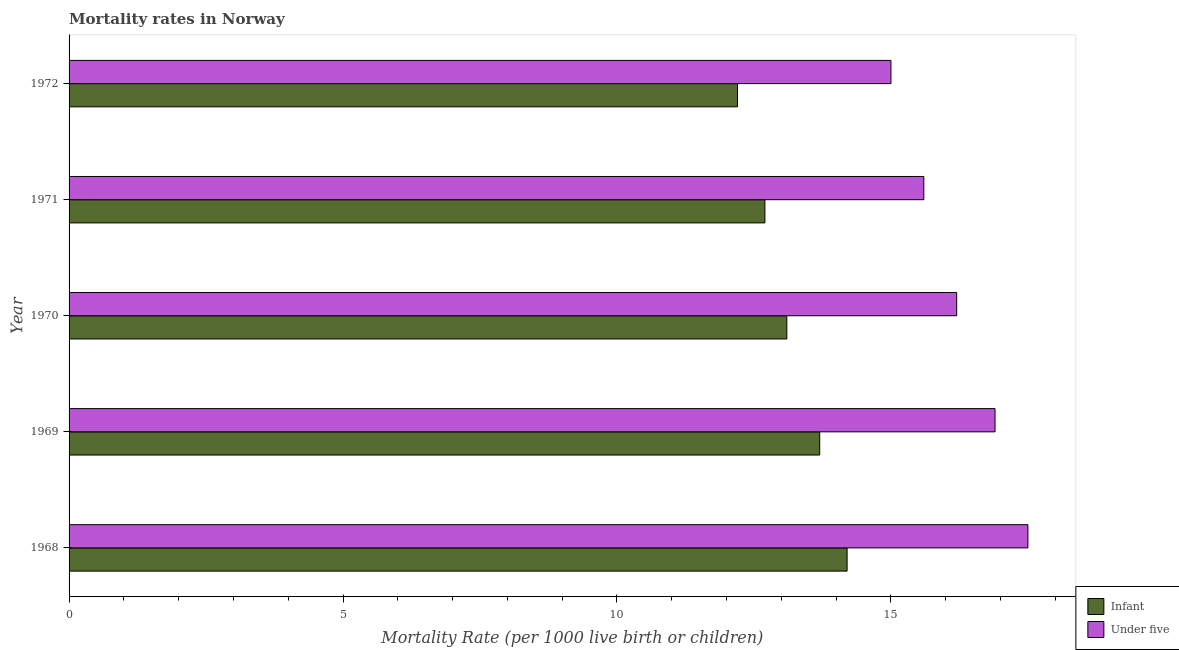How many groups of bars are there?
Your response must be concise. 5. What is the label of the 5th group of bars from the top?
Provide a succinct answer. 1968. In how many cases, is the number of bars for a given year not equal to the number of legend labels?
Your answer should be compact. 0. Across all years, what is the maximum under-5 mortality rate?
Keep it short and to the point. 17.5. Across all years, what is the minimum under-5 mortality rate?
Your answer should be very brief. 15. In which year was the infant mortality rate maximum?
Your answer should be compact. 1968. What is the total under-5 mortality rate in the graph?
Your response must be concise. 81.2. What is the difference between the infant mortality rate in 1968 and that in 1969?
Give a very brief answer. 0.5. What is the difference between the infant mortality rate in 1968 and the under-5 mortality rate in 1969?
Offer a very short reply. -2.7. What is the average infant mortality rate per year?
Offer a very short reply. 13.18. What is the ratio of the infant mortality rate in 1969 to that in 1972?
Your response must be concise. 1.12. What is the difference between the highest and the second highest infant mortality rate?
Keep it short and to the point. 0.5. What is the difference between the highest and the lowest under-5 mortality rate?
Your answer should be very brief. 2.5. In how many years, is the infant mortality rate greater than the average infant mortality rate taken over all years?
Give a very brief answer. 2. What does the 1st bar from the top in 1970 represents?
Keep it short and to the point. Under five. What does the 1st bar from the bottom in 1972 represents?
Provide a short and direct response. Infant. How many bars are there?
Your answer should be compact. 10. What is the difference between two consecutive major ticks on the X-axis?
Ensure brevity in your answer.  5. Are the values on the major ticks of X-axis written in scientific E-notation?
Offer a terse response. No. Does the graph contain any zero values?
Keep it short and to the point. No. Does the graph contain grids?
Your answer should be compact. No. How many legend labels are there?
Your response must be concise. 2. What is the title of the graph?
Provide a short and direct response. Mortality rates in Norway. What is the label or title of the X-axis?
Provide a short and direct response. Mortality Rate (per 1000 live birth or children). What is the Mortality Rate (per 1000 live birth or children) in Infant in 1968?
Offer a terse response. 14.2. What is the Mortality Rate (per 1000 live birth or children) of Under five in 1968?
Offer a terse response. 17.5. What is the Mortality Rate (per 1000 live birth or children) in Infant in 1969?
Your response must be concise. 13.7. What is the Mortality Rate (per 1000 live birth or children) of Under five in 1969?
Your response must be concise. 16.9. What is the Mortality Rate (per 1000 live birth or children) in Infant in 1970?
Provide a succinct answer. 13.1. Across all years, what is the maximum Mortality Rate (per 1000 live birth or children) of Infant?
Make the answer very short. 14.2. Across all years, what is the maximum Mortality Rate (per 1000 live birth or children) of Under five?
Offer a terse response. 17.5. What is the total Mortality Rate (per 1000 live birth or children) of Infant in the graph?
Provide a succinct answer. 65.9. What is the total Mortality Rate (per 1000 live birth or children) in Under five in the graph?
Offer a very short reply. 81.2. What is the difference between the Mortality Rate (per 1000 live birth or children) in Under five in 1968 and that in 1969?
Ensure brevity in your answer.  0.6. What is the difference between the Mortality Rate (per 1000 live birth or children) of Infant in 1968 and that in 1970?
Ensure brevity in your answer.  1.1. What is the difference between the Mortality Rate (per 1000 live birth or children) of Infant in 1969 and that in 1970?
Keep it short and to the point. 0.6. What is the difference between the Mortality Rate (per 1000 live birth or children) of Infant in 1969 and that in 1971?
Your answer should be very brief. 1. What is the difference between the Mortality Rate (per 1000 live birth or children) of Under five in 1969 and that in 1971?
Offer a very short reply. 1.3. What is the difference between the Mortality Rate (per 1000 live birth or children) in Infant in 1969 and that in 1972?
Ensure brevity in your answer.  1.5. What is the difference between the Mortality Rate (per 1000 live birth or children) of Under five in 1969 and that in 1972?
Your response must be concise. 1.9. What is the difference between the Mortality Rate (per 1000 live birth or children) of Infant in 1970 and that in 1972?
Make the answer very short. 0.9. What is the difference between the Mortality Rate (per 1000 live birth or children) in Under five in 1970 and that in 1972?
Keep it short and to the point. 1.2. What is the difference between the Mortality Rate (per 1000 live birth or children) of Infant in 1968 and the Mortality Rate (per 1000 live birth or children) of Under five in 1969?
Give a very brief answer. -2.7. What is the difference between the Mortality Rate (per 1000 live birth or children) in Infant in 1968 and the Mortality Rate (per 1000 live birth or children) in Under five in 1971?
Ensure brevity in your answer.  -1.4. What is the difference between the Mortality Rate (per 1000 live birth or children) in Infant in 1969 and the Mortality Rate (per 1000 live birth or children) in Under five in 1970?
Offer a terse response. -2.5. What is the difference between the Mortality Rate (per 1000 live birth or children) of Infant in 1969 and the Mortality Rate (per 1000 live birth or children) of Under five in 1971?
Ensure brevity in your answer.  -1.9. What is the difference between the Mortality Rate (per 1000 live birth or children) in Infant in 1970 and the Mortality Rate (per 1000 live birth or children) in Under five in 1972?
Keep it short and to the point. -1.9. What is the average Mortality Rate (per 1000 live birth or children) of Infant per year?
Ensure brevity in your answer.  13.18. What is the average Mortality Rate (per 1000 live birth or children) in Under five per year?
Your response must be concise. 16.24. In the year 1969, what is the difference between the Mortality Rate (per 1000 live birth or children) of Infant and Mortality Rate (per 1000 live birth or children) of Under five?
Offer a terse response. -3.2. In the year 1971, what is the difference between the Mortality Rate (per 1000 live birth or children) of Infant and Mortality Rate (per 1000 live birth or children) of Under five?
Make the answer very short. -2.9. In the year 1972, what is the difference between the Mortality Rate (per 1000 live birth or children) in Infant and Mortality Rate (per 1000 live birth or children) in Under five?
Keep it short and to the point. -2.8. What is the ratio of the Mortality Rate (per 1000 live birth or children) of Infant in 1968 to that in 1969?
Your response must be concise. 1.04. What is the ratio of the Mortality Rate (per 1000 live birth or children) in Under five in 1968 to that in 1969?
Your response must be concise. 1.04. What is the ratio of the Mortality Rate (per 1000 live birth or children) in Infant in 1968 to that in 1970?
Provide a short and direct response. 1.08. What is the ratio of the Mortality Rate (per 1000 live birth or children) of Under five in 1968 to that in 1970?
Make the answer very short. 1.08. What is the ratio of the Mortality Rate (per 1000 live birth or children) in Infant in 1968 to that in 1971?
Give a very brief answer. 1.12. What is the ratio of the Mortality Rate (per 1000 live birth or children) in Under five in 1968 to that in 1971?
Keep it short and to the point. 1.12. What is the ratio of the Mortality Rate (per 1000 live birth or children) of Infant in 1968 to that in 1972?
Keep it short and to the point. 1.16. What is the ratio of the Mortality Rate (per 1000 live birth or children) in Infant in 1969 to that in 1970?
Keep it short and to the point. 1.05. What is the ratio of the Mortality Rate (per 1000 live birth or children) of Under five in 1969 to that in 1970?
Your answer should be very brief. 1.04. What is the ratio of the Mortality Rate (per 1000 live birth or children) in Infant in 1969 to that in 1971?
Your response must be concise. 1.08. What is the ratio of the Mortality Rate (per 1000 live birth or children) of Under five in 1969 to that in 1971?
Your response must be concise. 1.08. What is the ratio of the Mortality Rate (per 1000 live birth or children) of Infant in 1969 to that in 1972?
Offer a very short reply. 1.12. What is the ratio of the Mortality Rate (per 1000 live birth or children) in Under five in 1969 to that in 1972?
Your response must be concise. 1.13. What is the ratio of the Mortality Rate (per 1000 live birth or children) in Infant in 1970 to that in 1971?
Your response must be concise. 1.03. What is the ratio of the Mortality Rate (per 1000 live birth or children) in Infant in 1970 to that in 1972?
Your answer should be very brief. 1.07. What is the ratio of the Mortality Rate (per 1000 live birth or children) of Infant in 1971 to that in 1972?
Provide a short and direct response. 1.04. What is the difference between the highest and the lowest Mortality Rate (per 1000 live birth or children) in Infant?
Your answer should be very brief. 2. 